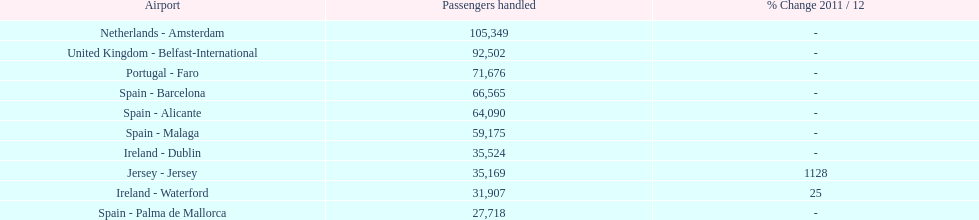How many airports are listed? 10. 